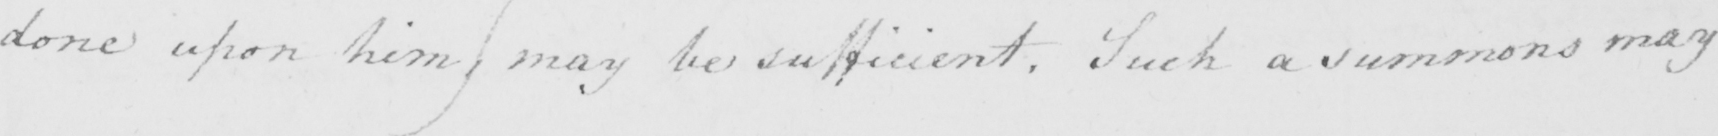Please transcribe the handwritten text in this image. done upon him )  may be sufficient . Such a summons may 